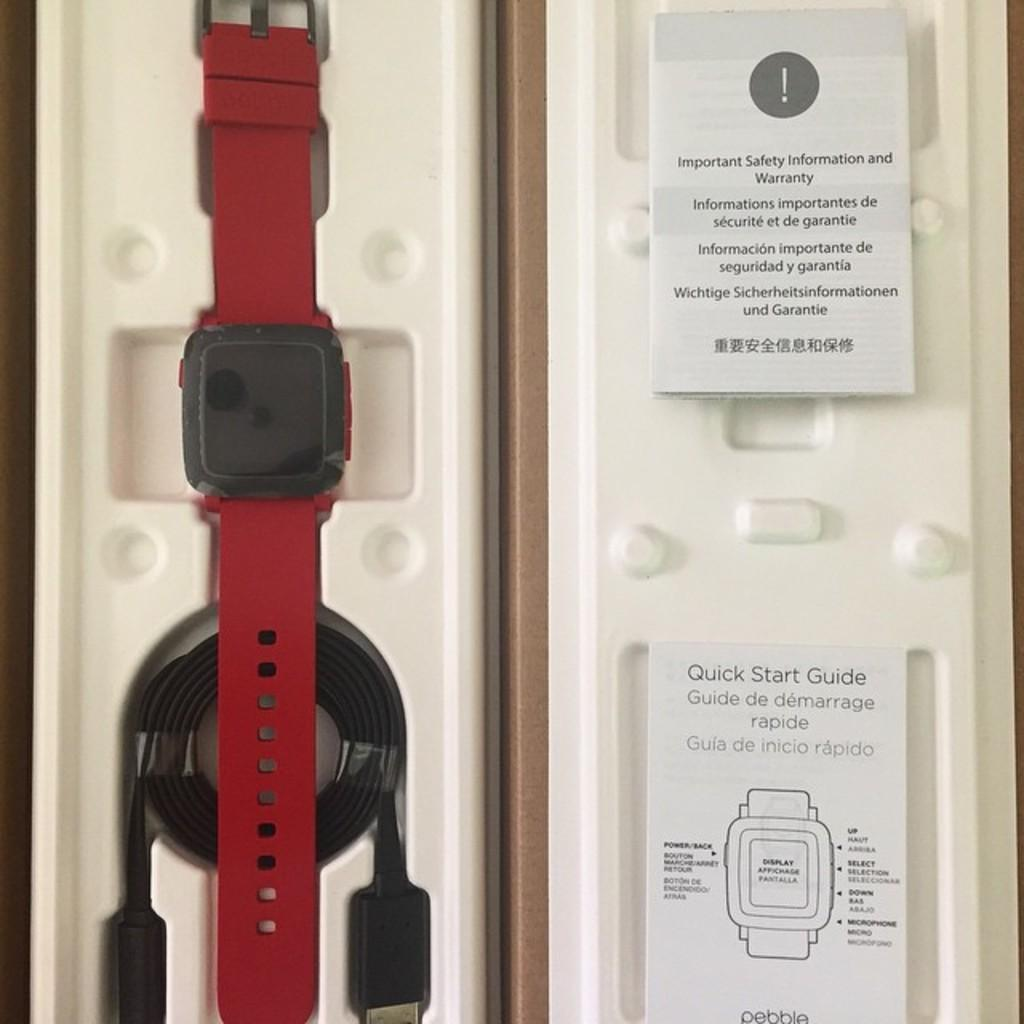<image>
Render a clear and concise summary of the photo. A smart watch with important safety information and a Quick start guide. 